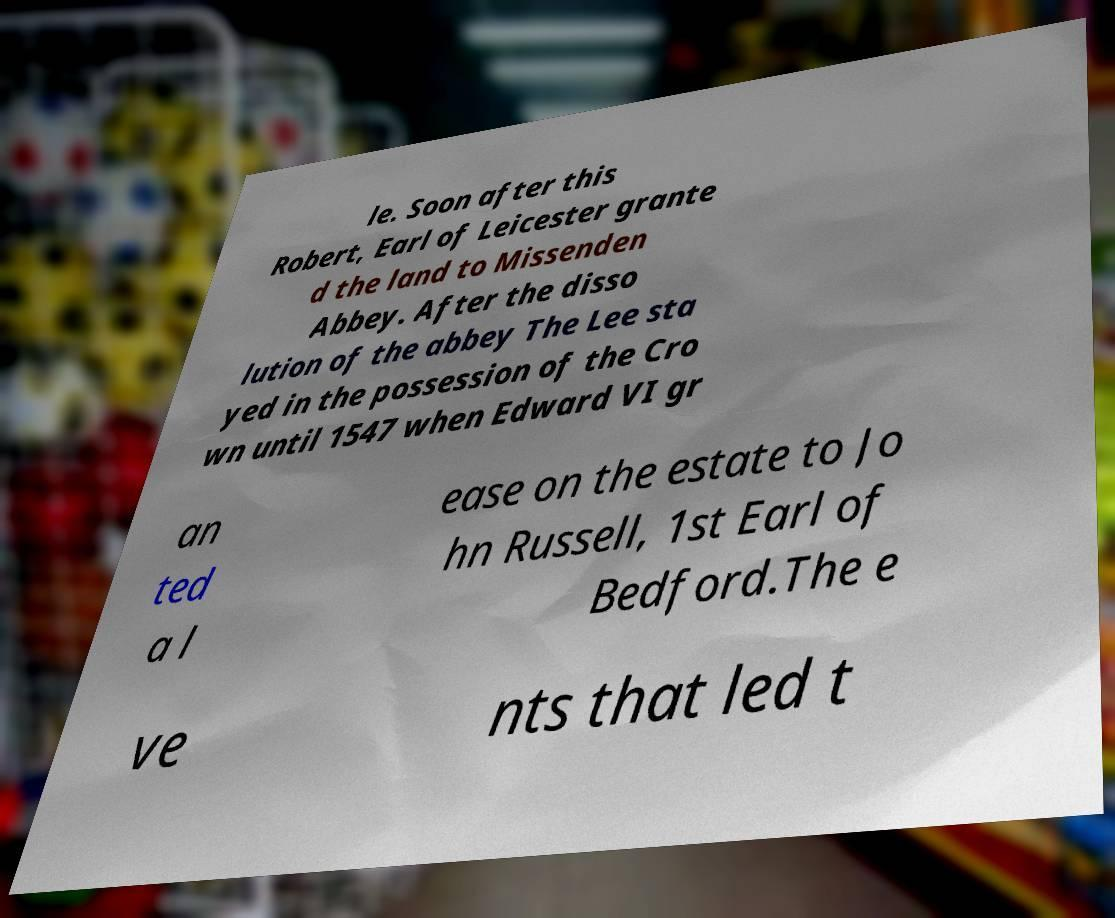Can you accurately transcribe the text from the provided image for me? le. Soon after this Robert, Earl of Leicester grante d the land to Missenden Abbey. After the disso lution of the abbey The Lee sta yed in the possession of the Cro wn until 1547 when Edward VI gr an ted a l ease on the estate to Jo hn Russell, 1st Earl of Bedford.The e ve nts that led t 